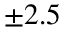Convert formula to latex. <formula><loc_0><loc_0><loc_500><loc_500>\pm 2 . 5</formula> 